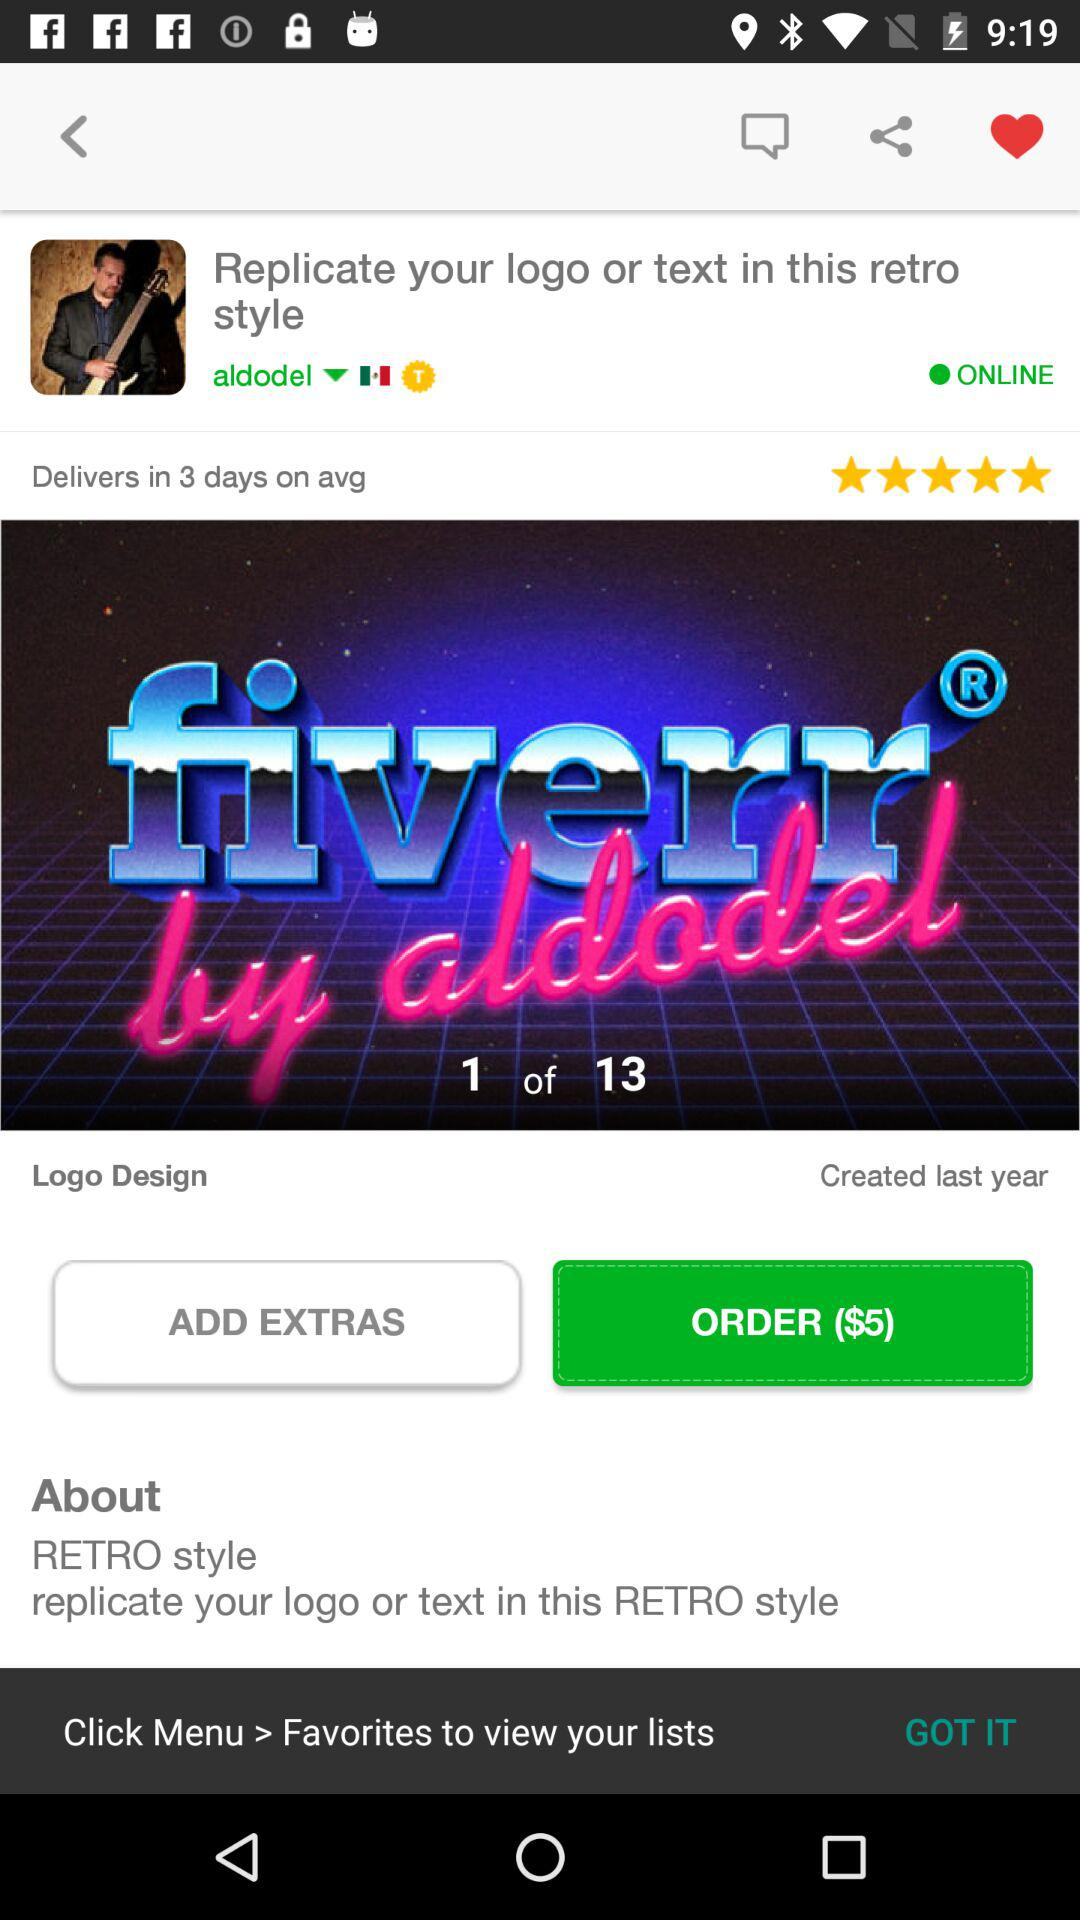How much does it cost to order? It costs $5 to order. 